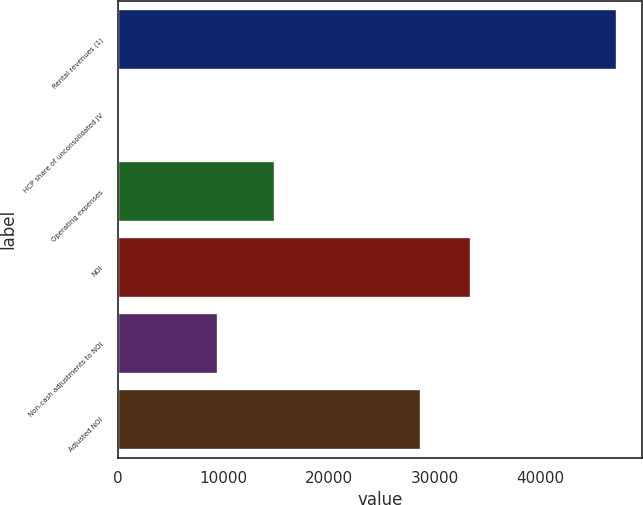Convert chart. <chart><loc_0><loc_0><loc_500><loc_500><bar_chart><fcel>Rental revenues (1)<fcel>HCP share of unconsolidated JV<fcel>Operating expenses<fcel>NOI<fcel>Non-cash adjustments to NOI<fcel>Adjusted NOI<nl><fcel>47296<fcel>41<fcel>14910<fcel>33473.5<fcel>9492<fcel>28748<nl></chart> 